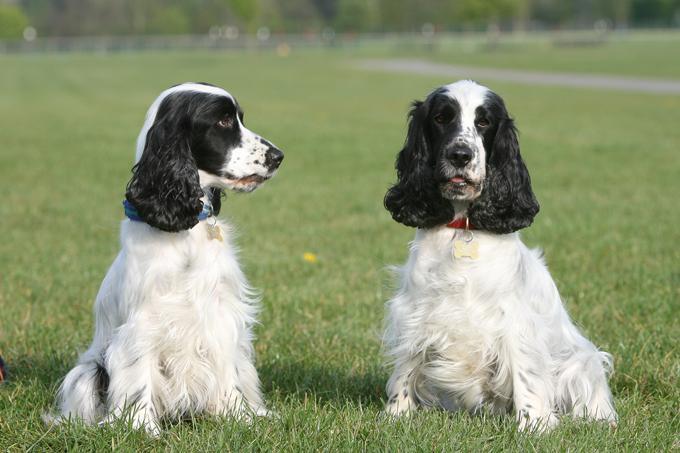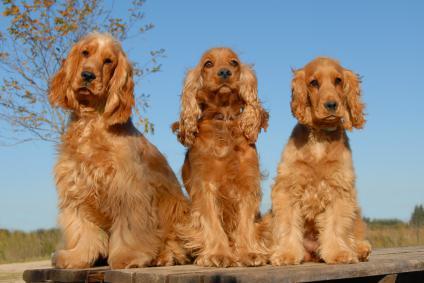The first image is the image on the left, the second image is the image on the right. Considering the images on both sides, is "Five spaniels are shown, in total." valid? Answer yes or no. Yes. The first image is the image on the left, the second image is the image on the right. Considering the images on both sides, is "There are multiple dogs in the right image and they are all the same color." valid? Answer yes or no. Yes. The first image is the image on the left, the second image is the image on the right. Examine the images to the left and right. Is the description "The right image contains exactly three dogs." accurate? Answer yes or no. Yes. 